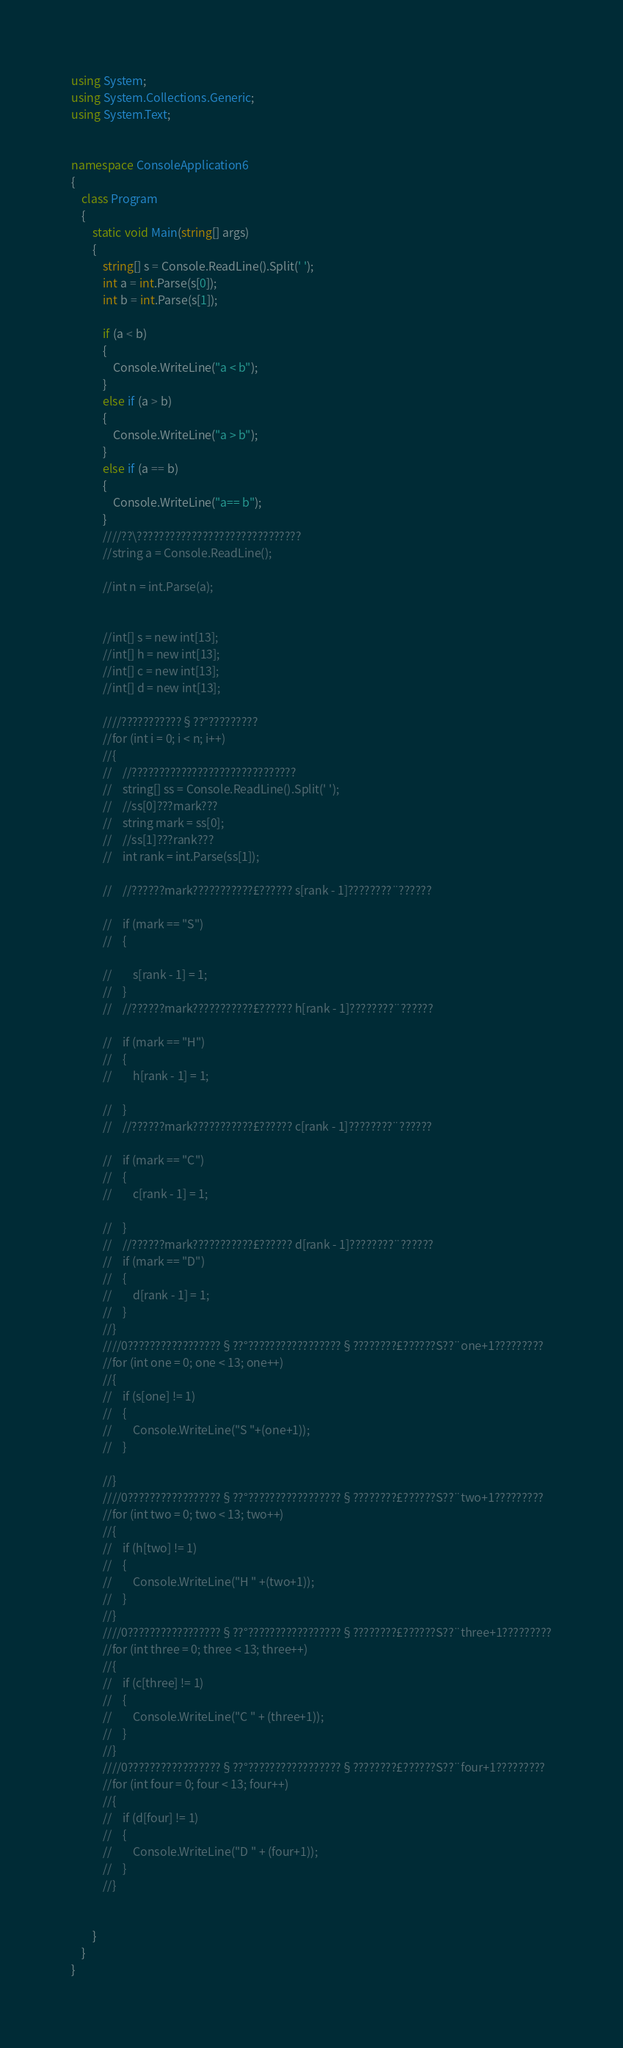<code> <loc_0><loc_0><loc_500><loc_500><_C#_>using System;
using System.Collections.Generic;
using System.Text;


namespace ConsoleApplication6
{
    class Program
    {
        static void Main(string[] args)
        {
            string[] s = Console.ReadLine().Split(' ');
            int a = int.Parse(s[0]);
            int b = int.Parse(s[1]);

            if (a < b)
            {
                Console.WriteLine("a < b"); 
            }
            else if (a > b)
            {
                Console.WriteLine("a > b");
            } 
            else if (a == b)
            {
                Console.WriteLine("a== b");
            }
            ////??\??????????????????????????????
            //string a = Console.ReadLine();
            
            //int n = int.Parse(a);


            //int[] s = new int[13];
            //int[] h = new int[13];
            //int[] c = new int[13];
            //int[] d = new int[13];

            ////???????????§??°?????????
            //for (int i = 0; i < n; i++)
            //{
            //    //??????????????????????????????
            //    string[] ss = Console.ReadLine().Split(' ');
            //    //ss[0]???mark???
            //    string mark = ss[0];
            //    //ss[1]???rank???
            //    int rank = int.Parse(ss[1]);

            //    //??????mark???????????£?????? s[rank - 1]????????¨??????
                
            //    if (mark == "S")
            //    {
            
            //        s[rank - 1] = 1;
            //    }
            //    //??????mark???????????£?????? h[rank - 1]????????¨??????
                
            //    if (mark == "H")
            //    {
            //        h[rank - 1] = 1;

            //    }
            //    //??????mark???????????£?????? c[rank - 1]????????¨??????
                
            //    if (mark == "C")
            //    {
            //        c[rank - 1] = 1;

            //    }
            //    //??????mark???????????£?????? d[rank - 1]????????¨??????
            //    if (mark == "D")
            //    {
            //        d[rank - 1] = 1;
            //    }
            //}
            ////0?????????????????§??°?????????????????§????????£??????S??¨one+1?????????
            //for (int one = 0; one < 13; one++) 
            //{
            //    if (s[one] != 1)
            //    {
            //        Console.WriteLine("S "+(one+1));
            //    }

            //}
            ////0?????????????????§??°?????????????????§????????£??????S??¨two+1?????????
            //for (int two = 0; two < 13; two++)
            //{
            //    if (h[two] != 1)
            //    {
            //        Console.WriteLine("H " +(two+1));
            //    }
            //}
            ////0?????????????????§??°?????????????????§????????£??????S??¨three+1?????????
            //for (int three = 0; three < 13; three++)
            //{
            //    if (c[three] != 1)
            //    {
            //        Console.WriteLine("C " + (three+1));
            //    }
            //}
            ////0?????????????????§??°?????????????????§????????£??????S??¨four+1?????????
            //for (int four = 0; four < 13; four++)
            //{
            //    if (d[four] != 1)
            //    {
            //        Console.WriteLine("D " + (four+1));
            //    }
            //}


        }
    }
}</code> 